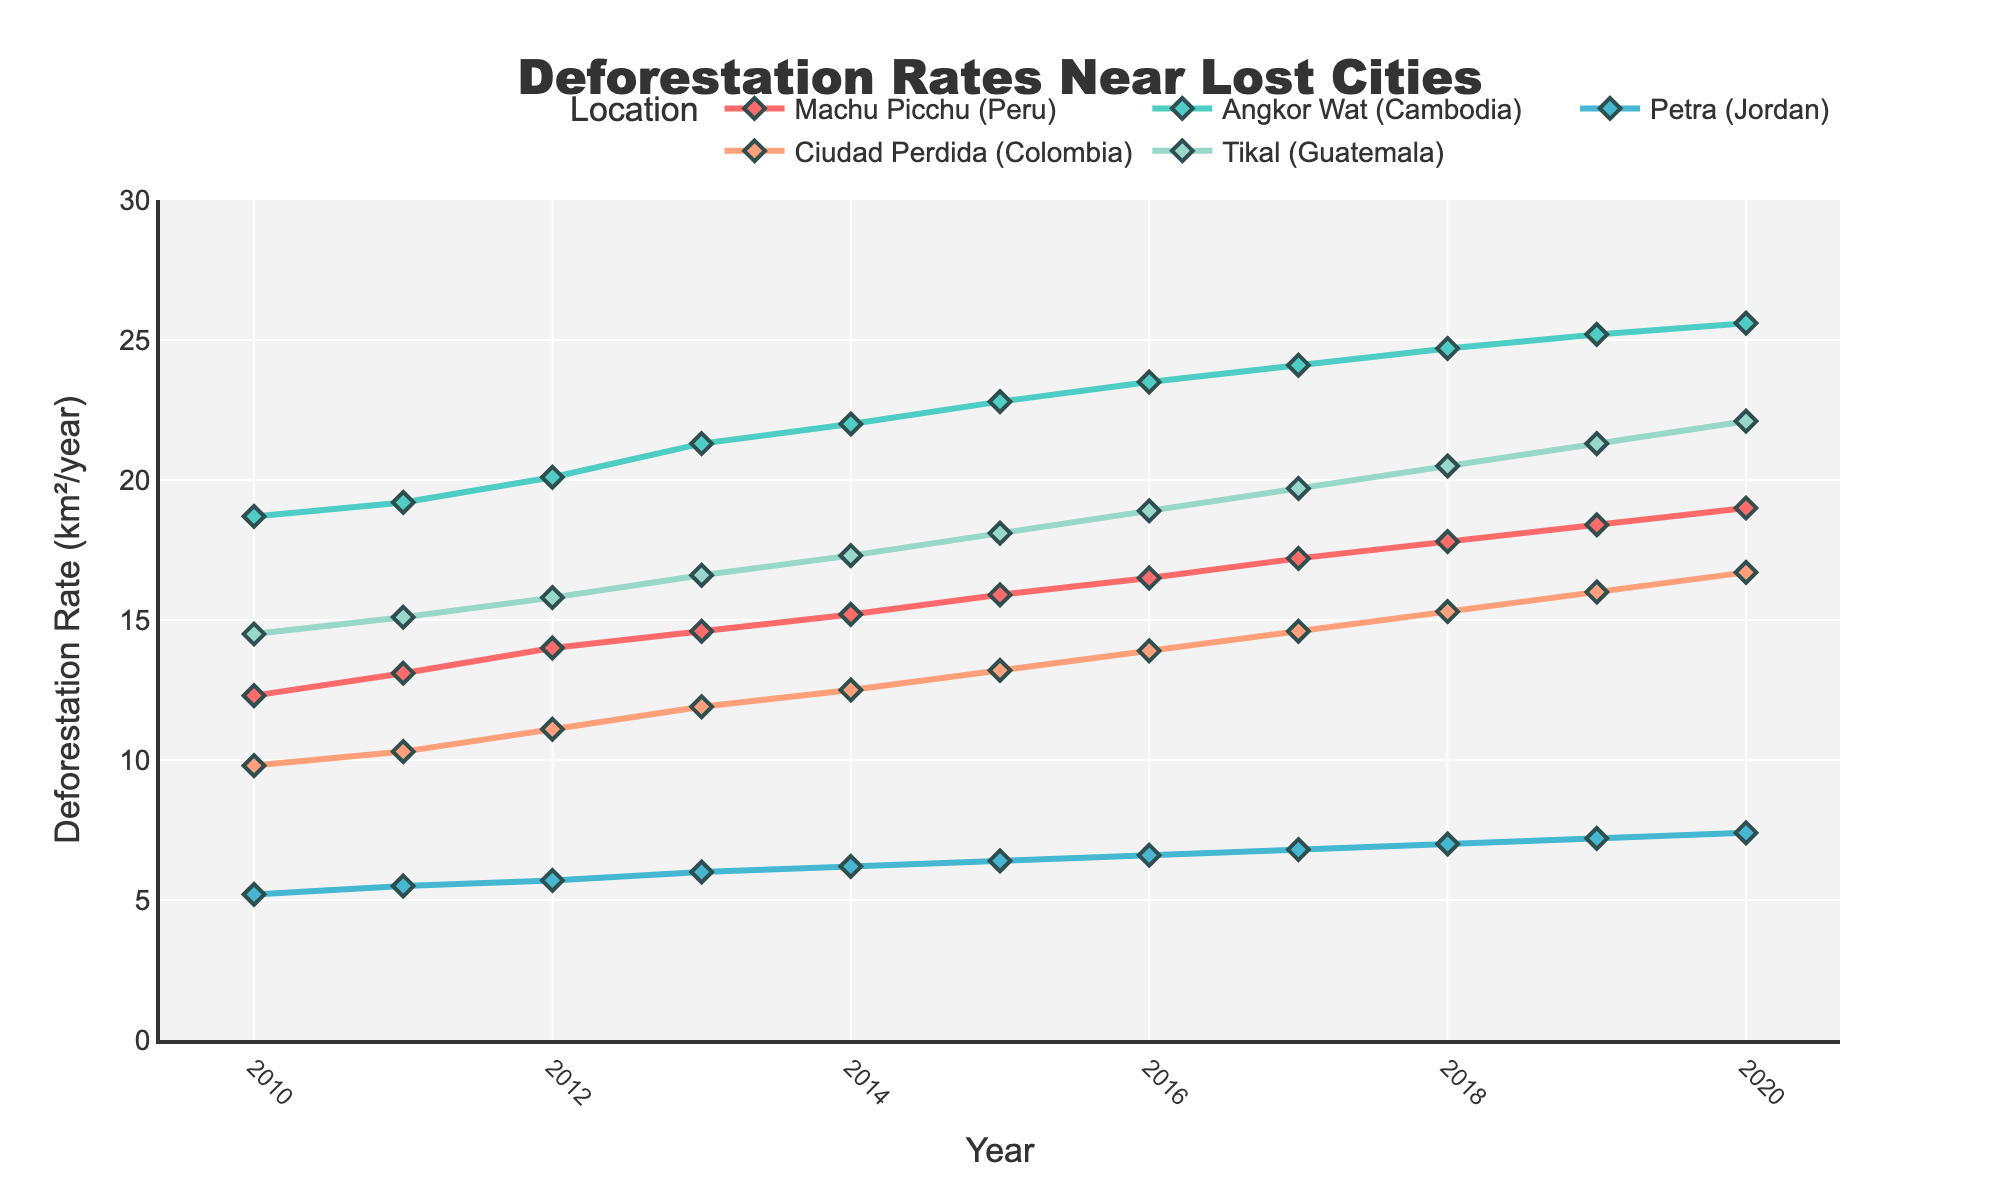What location had the highest deforestation rate in 2015? In the 2015 row, compare the values for each site: Machu Picchu (15.9), Angkor Wat (22.8), Petra (6.4), Ciudad Perdida (13.2), and Tikal (18.1). Angkor Wat has the highest rate.
Answer: Angkor Wat Which location shows the greatest overall increase in deforestation rate from 2010 to 2020? Calculate the difference for each location between 2010 and 2020. Machu Picchu (19.0-12.3=6.7), Angkor Wat (25.6-18.7=6.9), Petra (7.4-5.2=2.2), Ciudad Perdida (16.7-9.8=6.9), and Tikal (22.1-14.5=7.6). Tikal has the greatest increase.
Answer: Tikal On average, how much did the deforestation rate increase per year for Machu Picchu between 2010 and 2020? Calculate the total increase (19.0-12.3=6.7) and divide by the number of years (2020-2010=10). 6.7/10=0.67 km²/year.
Answer: 0.67 km²/year Which year did Ciudad Perdida experience the highest rate of deforestation? Scan through the Ciudad Perdida column and identify the maximum value. The highest rate is in 2020 with 16.7 km²/year.
Answer: 2020 For which location is the deforestation rate change the most consistent across the years? Look at the shape of the lines for each location; the line with the least variation in slope indicates consistent change. Angkor Wat shows a very steady, almost linear increase.
Answer: Angkor Wat Which location had the smallest deforestation rate in 2013? Compare all the 2013 values: Machu Picchu (14.6), Angkor Wat (21.3), Petra (6.0), Ciudad Perdida (11.9), and Tikal (16.6). Petra has the smallest with 6.0 km²/year.
Answer: Petra What is the total deforestation rate for all locations combined in 2017? Sum the values for 2017: Machu Picchu (17.2), Angkor Wat (24.1), Petra (6.8), Ciudad Perdida (14.6), Tikal (19.7). Total is 17.2 + 24.1 + 6.8 + 14.6 + 19.7 = 82.4.
Answer: 82.4 km²/year By what percentage did the deforestation rate for Tikal increase from 2010 to 2020? Calculate the percentage increase: ((22.1-14.5)/14.5) * 100 = 52.41%.
Answer: 52.41% Between which consecutive years did Petra see the largest increase in deforestation rate? Compare consecutive year differences for Petra: 2010-2011 (5.5-5.2=0.3), 2011-2012 (5.7-5.5=0.2), 2012-2013 (6.0-5.7=0.3), 2013-2014 (6.2-6.0=0.2), 2014-2015 (6.4-6.2=0.2), 2015-2016 (6.6-6.4=0.2), 2016-2017 (6.8-6.6=0.2), 2017-2018 (7.0-6.8=0.2), 2018-2019 (7.2-7.0=0.2), 2019-2020 (7.4-7.2=0.2). The largest increase is between 2010 and 2011 with 0.3 km²/year.
Answer: 2010-2011 Which location had a higher deforestation rate in 2016, Machu Picchu or Ciudad Perdida? Compare the 2016 values: Machu Picchu (16.5) and Ciudad Perdida (13.9). Machu Picchu has a higher rate.
Answer: Machu Picchu 